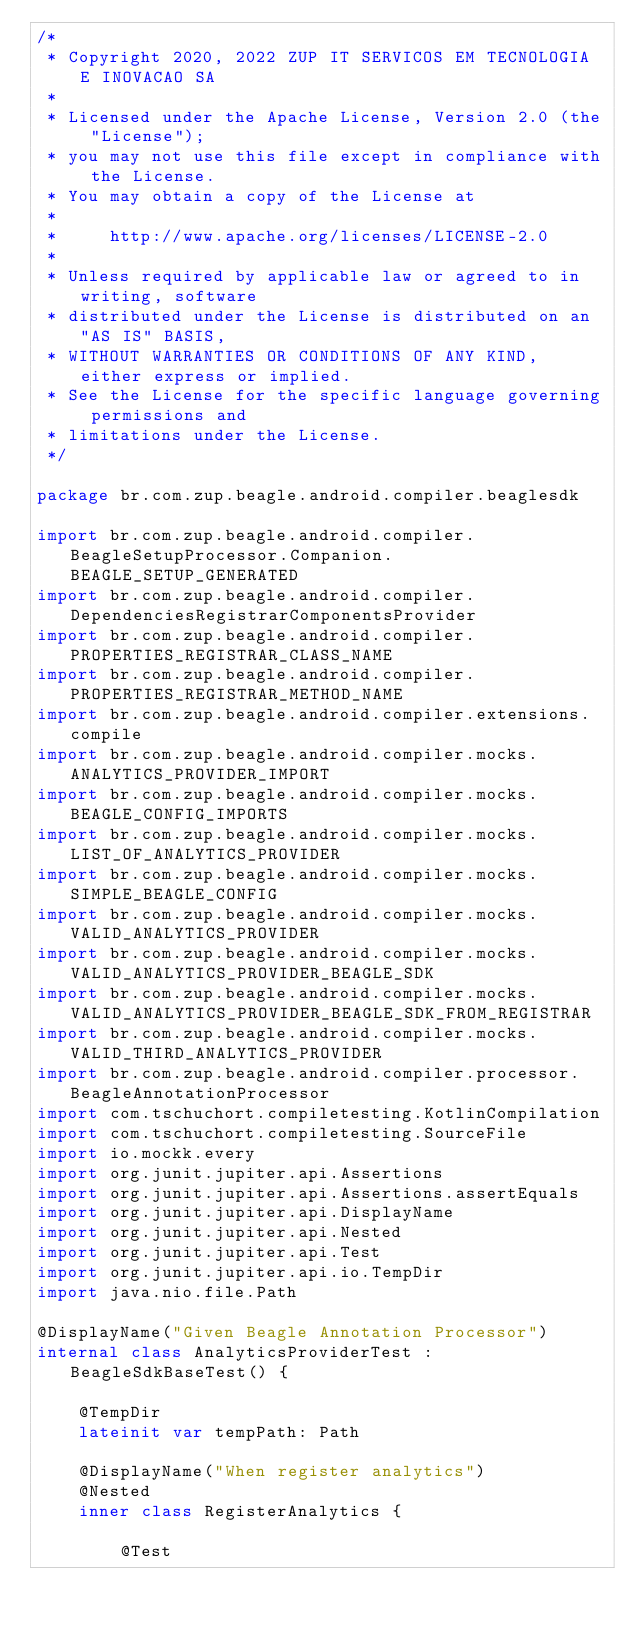Convert code to text. <code><loc_0><loc_0><loc_500><loc_500><_Kotlin_>/*
 * Copyright 2020, 2022 ZUP IT SERVICOS EM TECNOLOGIA E INOVACAO SA
 *
 * Licensed under the Apache License, Version 2.0 (the "License");
 * you may not use this file except in compliance with the License.
 * You may obtain a copy of the License at
 *
 *     http://www.apache.org/licenses/LICENSE-2.0
 *
 * Unless required by applicable law or agreed to in writing, software
 * distributed under the License is distributed on an "AS IS" BASIS,
 * WITHOUT WARRANTIES OR CONDITIONS OF ANY KIND, either express or implied.
 * See the License for the specific language governing permissions and
 * limitations under the License.
 */

package br.com.zup.beagle.android.compiler.beaglesdk

import br.com.zup.beagle.android.compiler.BeagleSetupProcessor.Companion.BEAGLE_SETUP_GENERATED
import br.com.zup.beagle.android.compiler.DependenciesRegistrarComponentsProvider
import br.com.zup.beagle.android.compiler.PROPERTIES_REGISTRAR_CLASS_NAME
import br.com.zup.beagle.android.compiler.PROPERTIES_REGISTRAR_METHOD_NAME
import br.com.zup.beagle.android.compiler.extensions.compile
import br.com.zup.beagle.android.compiler.mocks.ANALYTICS_PROVIDER_IMPORT
import br.com.zup.beagle.android.compiler.mocks.BEAGLE_CONFIG_IMPORTS
import br.com.zup.beagle.android.compiler.mocks.LIST_OF_ANALYTICS_PROVIDER
import br.com.zup.beagle.android.compiler.mocks.SIMPLE_BEAGLE_CONFIG
import br.com.zup.beagle.android.compiler.mocks.VALID_ANALYTICS_PROVIDER
import br.com.zup.beagle.android.compiler.mocks.VALID_ANALYTICS_PROVIDER_BEAGLE_SDK
import br.com.zup.beagle.android.compiler.mocks.VALID_ANALYTICS_PROVIDER_BEAGLE_SDK_FROM_REGISTRAR
import br.com.zup.beagle.android.compiler.mocks.VALID_THIRD_ANALYTICS_PROVIDER
import br.com.zup.beagle.android.compiler.processor.BeagleAnnotationProcessor
import com.tschuchort.compiletesting.KotlinCompilation
import com.tschuchort.compiletesting.SourceFile
import io.mockk.every
import org.junit.jupiter.api.Assertions
import org.junit.jupiter.api.Assertions.assertEquals
import org.junit.jupiter.api.DisplayName
import org.junit.jupiter.api.Nested
import org.junit.jupiter.api.Test
import org.junit.jupiter.api.io.TempDir
import java.nio.file.Path

@DisplayName("Given Beagle Annotation Processor")
internal class AnalyticsProviderTest : BeagleSdkBaseTest() {

    @TempDir
    lateinit var tempPath: Path

    @DisplayName("When register analytics")
    @Nested
    inner class RegisterAnalytics {

        @Test</code> 